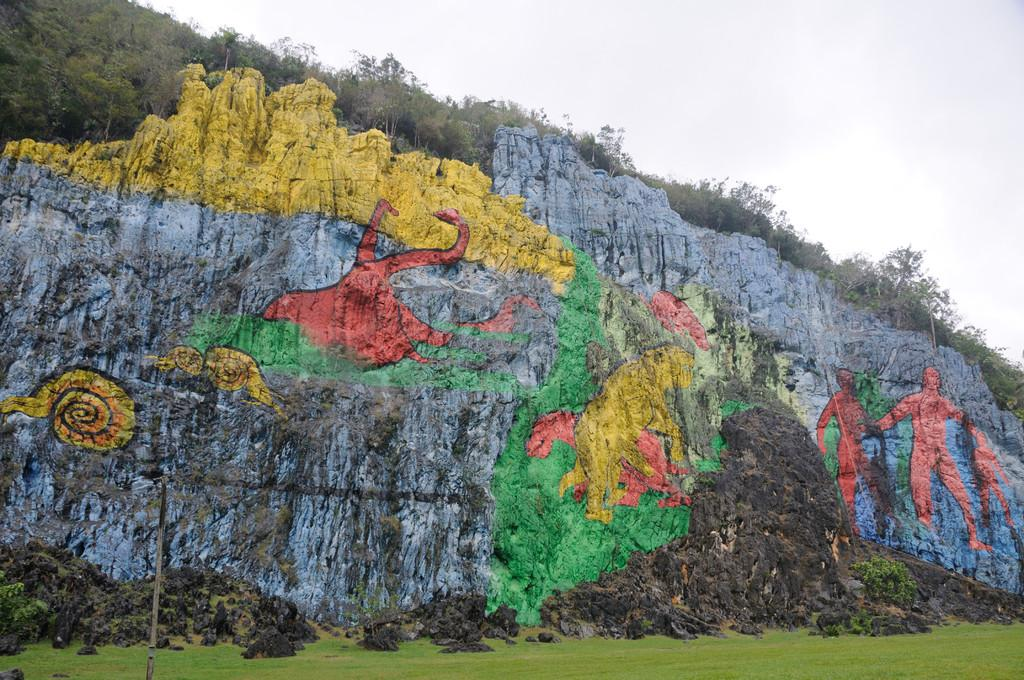What is the main subject in the center of the image? There is a mountain in the center of the image. What is unique about the mountain? The mountain has a painting on it. What type of vegetation can be seen in the image? There are trees in the image. What is at the bottom of the mountain? There is grass at the bottom of the image. What is visible at the top of the image? The sky is visible at the top of the image. How does the comb help the mountain breathe in the image? There is no comb or indication of breathing in the image; it features a mountain with a painting on it, trees, grass, and a visible sky. 